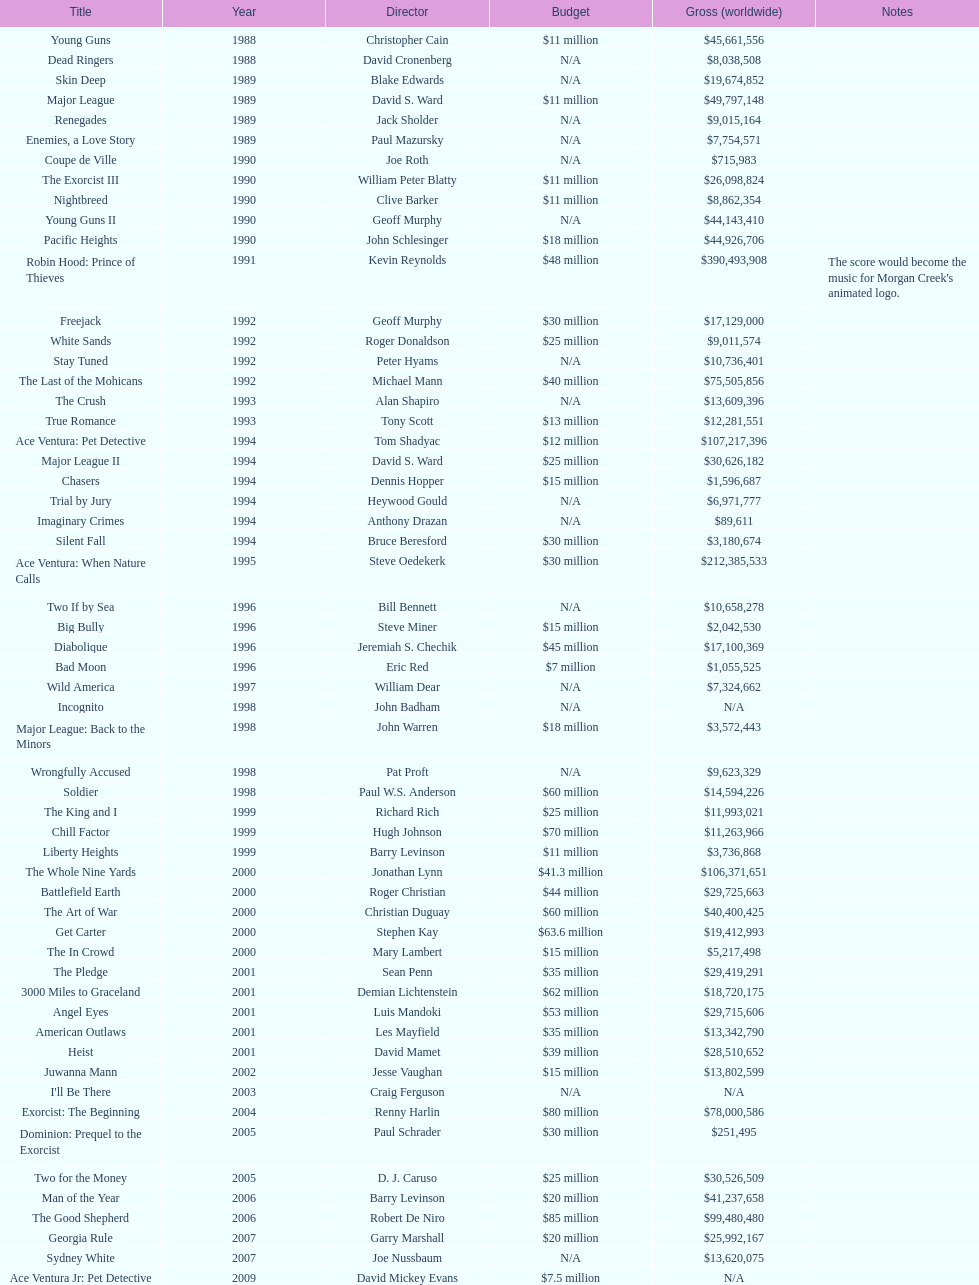Give me the full table as a dictionary. {'header': ['Title', 'Year', 'Director', 'Budget', 'Gross (worldwide)', 'Notes'], 'rows': [['Young Guns', '1988', 'Christopher Cain', '$11 million', '$45,661,556', ''], ['Dead Ringers', '1988', 'David Cronenberg', 'N/A', '$8,038,508', ''], ['Skin Deep', '1989', 'Blake Edwards', 'N/A', '$19,674,852', ''], ['Major League', '1989', 'David S. Ward', '$11 million', '$49,797,148', ''], ['Renegades', '1989', 'Jack Sholder', 'N/A', '$9,015,164', ''], ['Enemies, a Love Story', '1989', 'Paul Mazursky', 'N/A', '$7,754,571', ''], ['Coupe de Ville', '1990', 'Joe Roth', 'N/A', '$715,983', ''], ['The Exorcist III', '1990', 'William Peter Blatty', '$11 million', '$26,098,824', ''], ['Nightbreed', '1990', 'Clive Barker', '$11 million', '$8,862,354', ''], ['Young Guns II', '1990', 'Geoff Murphy', 'N/A', '$44,143,410', ''], ['Pacific Heights', '1990', 'John Schlesinger', '$18 million', '$44,926,706', ''], ['Robin Hood: Prince of Thieves', '1991', 'Kevin Reynolds', '$48 million', '$390,493,908', "The score would become the music for Morgan Creek's animated logo."], ['Freejack', '1992', 'Geoff Murphy', '$30 million', '$17,129,000', ''], ['White Sands', '1992', 'Roger Donaldson', '$25 million', '$9,011,574', ''], ['Stay Tuned', '1992', 'Peter Hyams', 'N/A', '$10,736,401', ''], ['The Last of the Mohicans', '1992', 'Michael Mann', '$40 million', '$75,505,856', ''], ['The Crush', '1993', 'Alan Shapiro', 'N/A', '$13,609,396', ''], ['True Romance', '1993', 'Tony Scott', '$13 million', '$12,281,551', ''], ['Ace Ventura: Pet Detective', '1994', 'Tom Shadyac', '$12 million', '$107,217,396', ''], ['Major League II', '1994', 'David S. Ward', '$25 million', '$30,626,182', ''], ['Chasers', '1994', 'Dennis Hopper', '$15 million', '$1,596,687', ''], ['Trial by Jury', '1994', 'Heywood Gould', 'N/A', '$6,971,777', ''], ['Imaginary Crimes', '1994', 'Anthony Drazan', 'N/A', '$89,611', ''], ['Silent Fall', '1994', 'Bruce Beresford', '$30 million', '$3,180,674', ''], ['Ace Ventura: When Nature Calls', '1995', 'Steve Oedekerk', '$30 million', '$212,385,533', ''], ['Two If by Sea', '1996', 'Bill Bennett', 'N/A', '$10,658,278', ''], ['Big Bully', '1996', 'Steve Miner', '$15 million', '$2,042,530', ''], ['Diabolique', '1996', 'Jeremiah S. Chechik', '$45 million', '$17,100,369', ''], ['Bad Moon', '1996', 'Eric Red', '$7 million', '$1,055,525', ''], ['Wild America', '1997', 'William Dear', 'N/A', '$7,324,662', ''], ['Incognito', '1998', 'John Badham', 'N/A', 'N/A', ''], ['Major League: Back to the Minors', '1998', 'John Warren', '$18 million', '$3,572,443', ''], ['Wrongfully Accused', '1998', 'Pat Proft', 'N/A', '$9,623,329', ''], ['Soldier', '1998', 'Paul W.S. Anderson', '$60 million', '$14,594,226', ''], ['The King and I', '1999', 'Richard Rich', '$25 million', '$11,993,021', ''], ['Chill Factor', '1999', 'Hugh Johnson', '$70 million', '$11,263,966', ''], ['Liberty Heights', '1999', 'Barry Levinson', '$11 million', '$3,736,868', ''], ['The Whole Nine Yards', '2000', 'Jonathan Lynn', '$41.3 million', '$106,371,651', ''], ['Battlefield Earth', '2000', 'Roger Christian', '$44 million', '$29,725,663', ''], ['The Art of War', '2000', 'Christian Duguay', '$60 million', '$40,400,425', ''], ['Get Carter', '2000', 'Stephen Kay', '$63.6 million', '$19,412,993', ''], ['The In Crowd', '2000', 'Mary Lambert', '$15 million', '$5,217,498', ''], ['The Pledge', '2001', 'Sean Penn', '$35 million', '$29,419,291', ''], ['3000 Miles to Graceland', '2001', 'Demian Lichtenstein', '$62 million', '$18,720,175', ''], ['Angel Eyes', '2001', 'Luis Mandoki', '$53 million', '$29,715,606', ''], ['American Outlaws', '2001', 'Les Mayfield', '$35 million', '$13,342,790', ''], ['Heist', '2001', 'David Mamet', '$39 million', '$28,510,652', ''], ['Juwanna Mann', '2002', 'Jesse Vaughan', '$15 million', '$13,802,599', ''], ["I'll Be There", '2003', 'Craig Ferguson', 'N/A', 'N/A', ''], ['Exorcist: The Beginning', '2004', 'Renny Harlin', '$80 million', '$78,000,586', ''], ['Dominion: Prequel to the Exorcist', '2005', 'Paul Schrader', '$30 million', '$251,495', ''], ['Two for the Money', '2005', 'D. J. Caruso', '$25 million', '$30,526,509', ''], ['Man of the Year', '2006', 'Barry Levinson', '$20 million', '$41,237,658', ''], ['The Good Shepherd', '2006', 'Robert De Niro', '$85 million', '$99,480,480', ''], ['Georgia Rule', '2007', 'Garry Marshall', '$20 million', '$25,992,167', ''], ['Sydney White', '2007', 'Joe Nussbaum', 'N/A', '$13,620,075', ''], ['Ace Ventura Jr: Pet Detective', '2009', 'David Mickey Evans', '$7.5 million', 'N/A', ''], ['Dream House', '2011', 'Jim Sheridan', '$50 million', '$38,502,340', ''], ['The Thing', '2011', 'Matthijs van Heijningen Jr.', '$38 million', '$27,428,670', ''], ['Tupac', '2014', 'Antoine Fuqua', '$45 million', '', '']]} Following young guns, which film had the identical budget? Major League. 